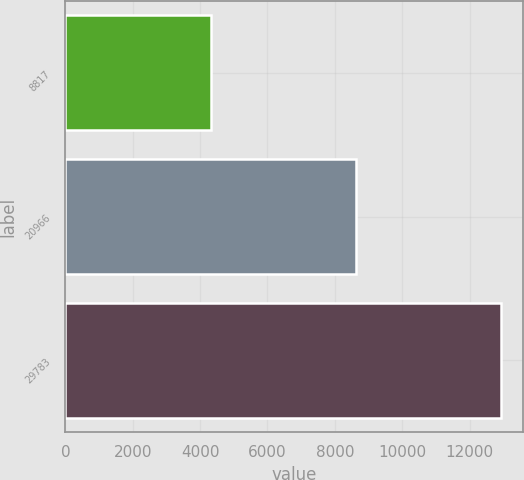Convert chart to OTSL. <chart><loc_0><loc_0><loc_500><loc_500><bar_chart><fcel>8817<fcel>20966<fcel>29783<nl><fcel>4317<fcel>8627<fcel>12944<nl></chart> 